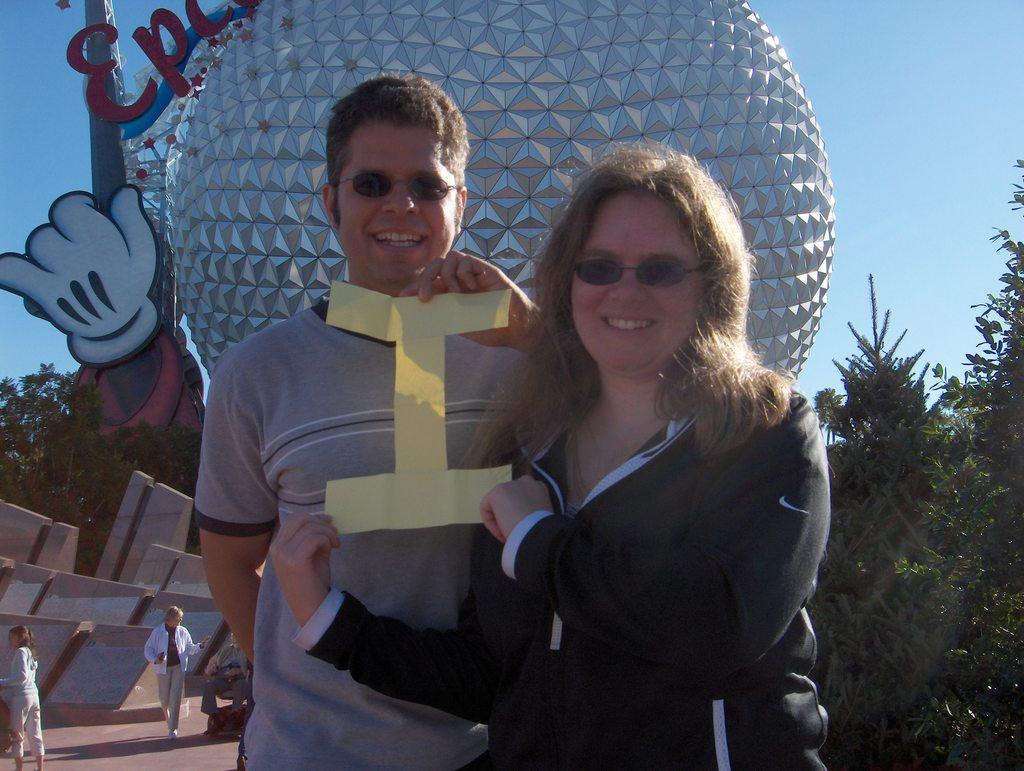How many people are standing in the front of the image? There are 2 people standing in the front of the image. What are the people wearing? The people are wearing goggles. What are the people holding in their hands? The people are holding a paper cutting in their hands. Can you describe the other people visible in the image? There are other people visible in the image, but their specific actions or items they are holding are not mentioned in the facts. What other objects or structures can be seen in the image? There is a sculpture and trees visible in the image. What type of cherry is being used to read the paper cutting in the image? There is no cherry present in the image, and the people are not using any cherry to read the paper cutting. Who is the governor in the image? There is no mention of a governor or any political figure in the image. 